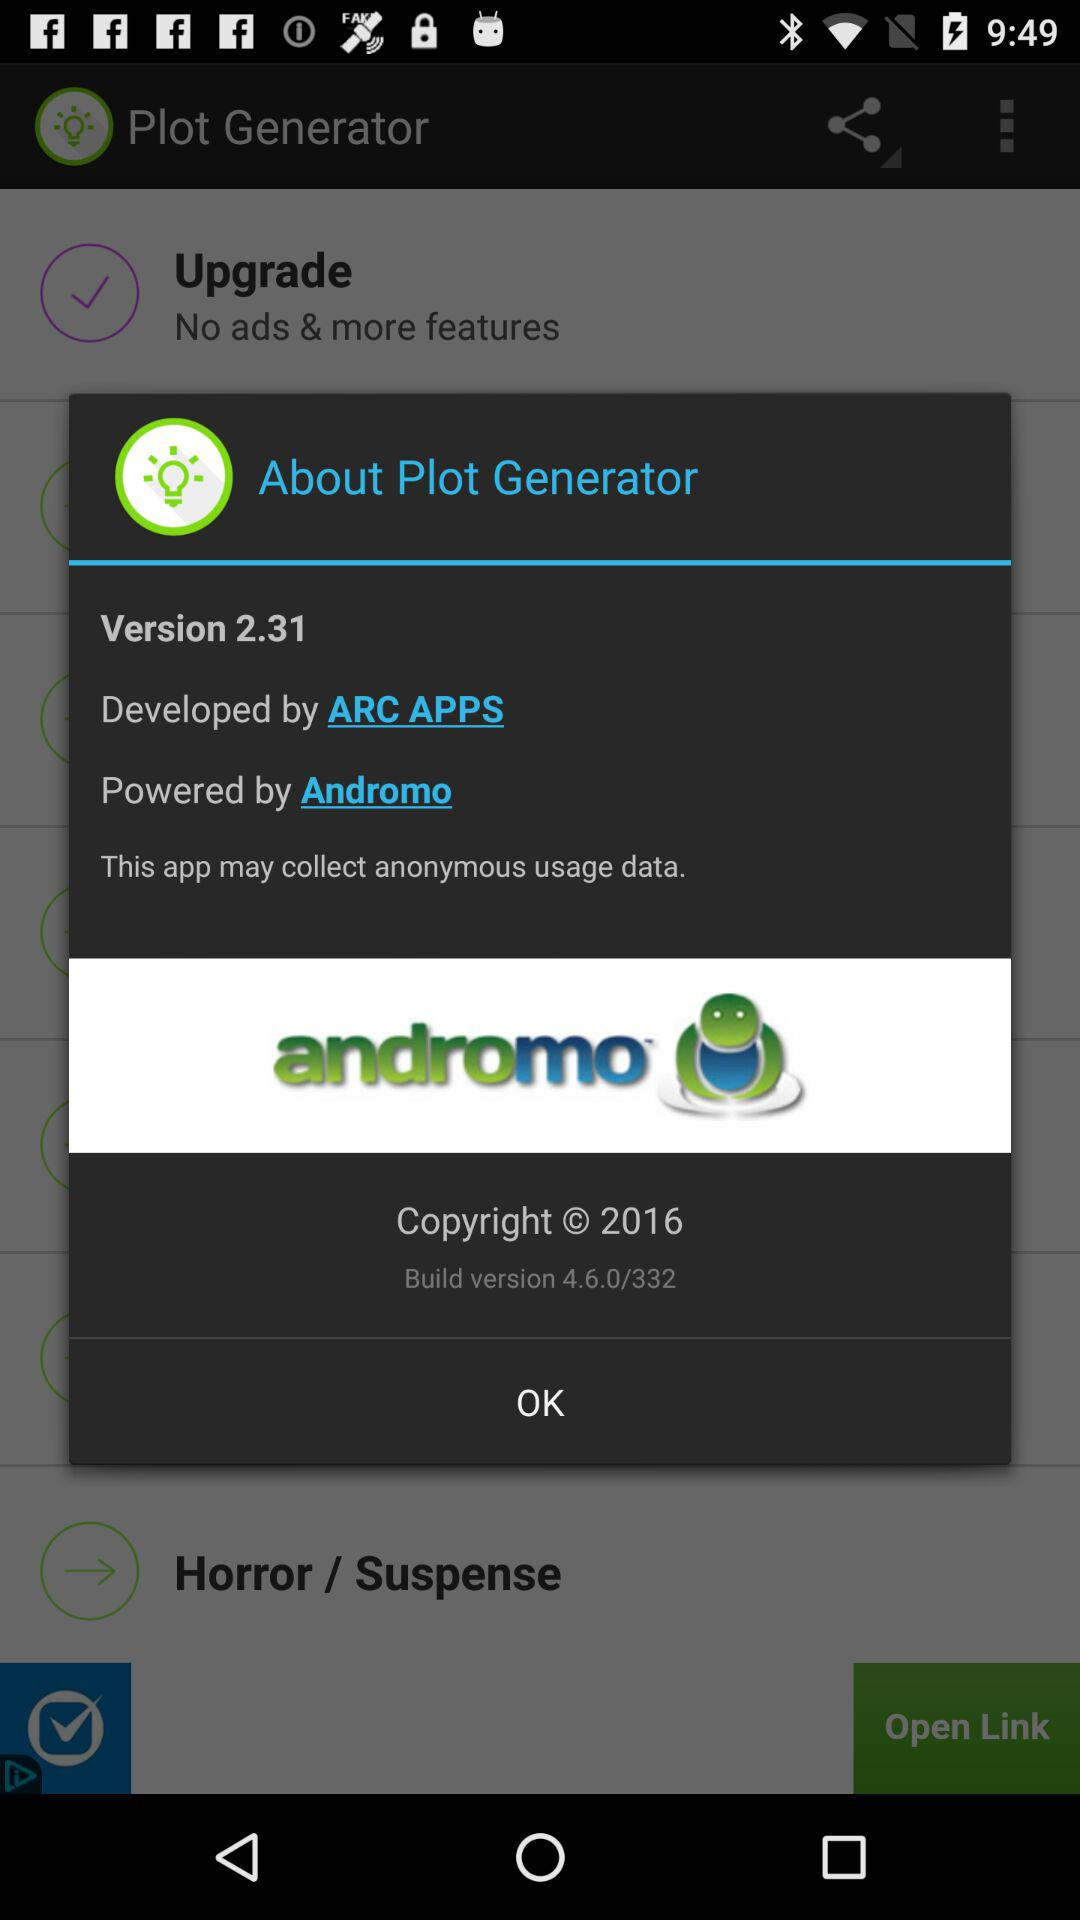What version of the application is used? The used version is 2.31. 